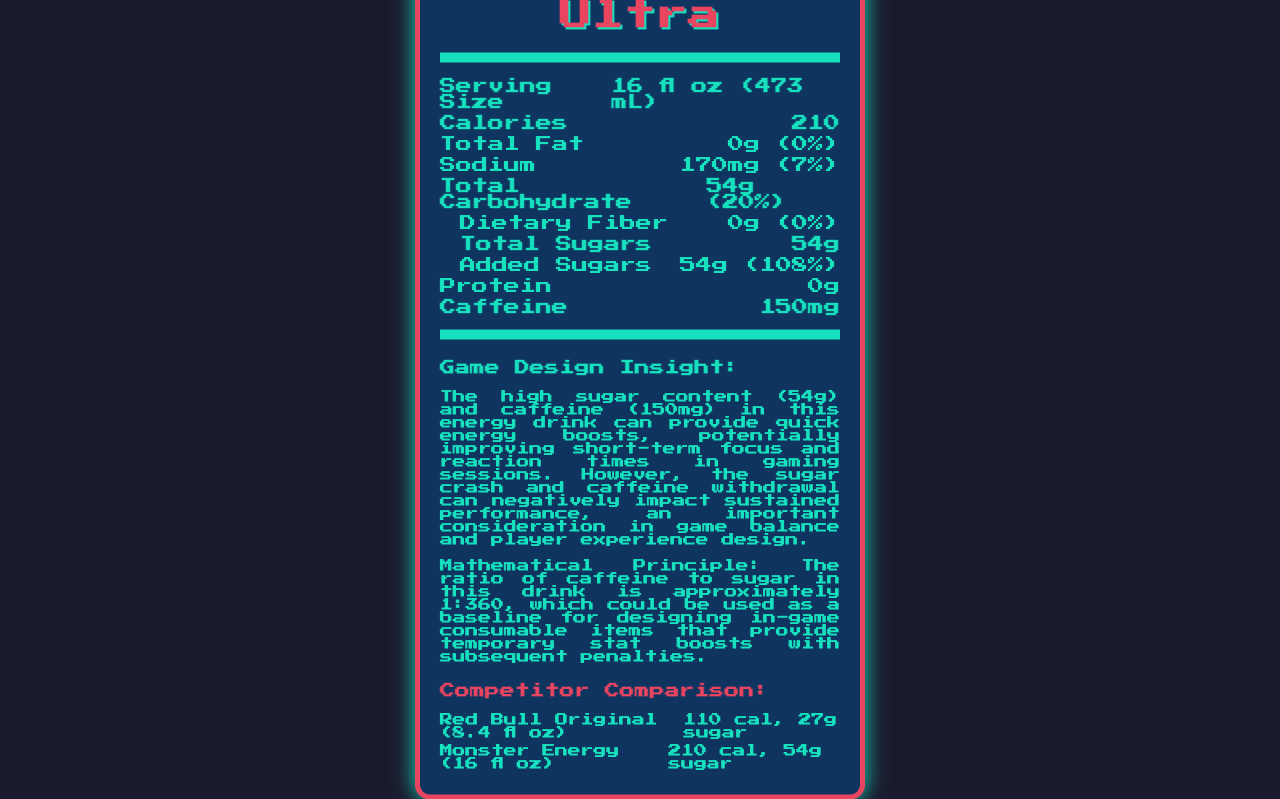what is the serving size of GameFuel Ultra? The document states that the serving size is 16 fl oz (473 mL).
Answer: 16 fl oz (473 mL) what is the total calorie count for one serving of GameFuel Ultra? The document indicates that one serving contains 210 calories.
Answer: 210 how much caffeine is in GameFuel Ultra per serving? The document lists the caffeine content as 150mg per serving.
Answer: 150mg how much sugar is in one serving of GameFuel Ultra? The document states that the total sugars in one serving amount to 54g.
Answer: 54g how much sodium does one serving of GameFuel Ultra contain? The document indicates that each serving contains 170mg of sodium.
Answer: 170mg which vitamin is provided in the highest daily percentage value in GameFuel Ultra? A. Vitamin B3 B. Vitamin B6 C. Vitamin B12 The document shows that Vitamin B12 is provided at 50% of the daily value, compared to Vitamin B3 (25%) and Vitamin B6 (18%).
Answer: C. Vitamin B12 what is the percentage daily value of added sugars in GameFuel Ultra? The document shows that added sugars constitute 108% of the daily value.
Answer: 108% which competitor energy drink has the highest caffeine content? A. GameFuel Ultra B. Red Bull Original C. Monster Energy Original The document indicates that Monster Energy Original contains 160mg of caffeine, which is higher than Red Bull Original (80mg) and GameFuel Ultra (150mg).
Answer: C. Monster Energy Original does GameFuel Ultra contain any protein? The document lists the protein content as 0g, indicating that there is no protein.
Answer: No how does the sugar content in GameFuel Ultra compare to that in Red Bull Original? The document indicates that GameFuel Ultra has 54g of sugar, while Red Bull Original has 27g.
Answer: GameFuel Ultra has twice the sugar content how does the calorie content of GameFuel Ultra compare to Monster Energy Original? The document states that both GameFuel Ultra and Monster Energy Original contain 210 calories per serving.
Answer: They have the same calorie content is the caffeine to sugar ratio in GameFuel Ultra higher, lower, or about the same as Monster Energy Original? The document states that the caffeine to sugar ratio for GameFuel Ultra is 1:360, which is lower than Monster Energy Original's ratio of approximately 1:337.5 (160mg caffeine to 54g sugar).
Answer: Lower what are the potential negative impacts of consuming GameFuel Ultra mentioned in the document? The document mentions that the high sugar and caffeine content can lead to a sugar crash and caffeine withdrawal, which can negatively impact sustained performance.
Answer: Sugar crash and caffeine withdrawal according to the document, what mathematical principle can be derived from the caffeine to sugar ratio in GameFuel Ultra? The document states this principle based on the caffeine to sugar ratio in GameFuel Ultra.
Answer: The ratio of caffeine to sugar is approximately 1:360, which can be used as a baseline for designing in-game consumable items that provide temporary stat boosts with subsequent penalties summarize the main idea of the document The explanation involves detailing nutritional contents, competitor comparison, game design insight, and mathematical principles as presented in the document.
Answer: The document provides detailed nutritional information about "GameFuel Ultra," an energy drink popular among gamers, including its high sugar and caffeine content. It compares this product to similar energy drinks such as Red Bull Original and Monster Energy Original. The document also offers a game design insight and a mathematical principle based on the caffeine to sugar ratio, indicating potential temporary benefits and subsequent downsides of consuming the drink. how does the total carbohydrate content in Monster Energy Original compare to GameFuel Ultra? The document does not provide the total carbohydrate content for Monster Energy Original, making this comparison impossible.
Answer: Not enough information 